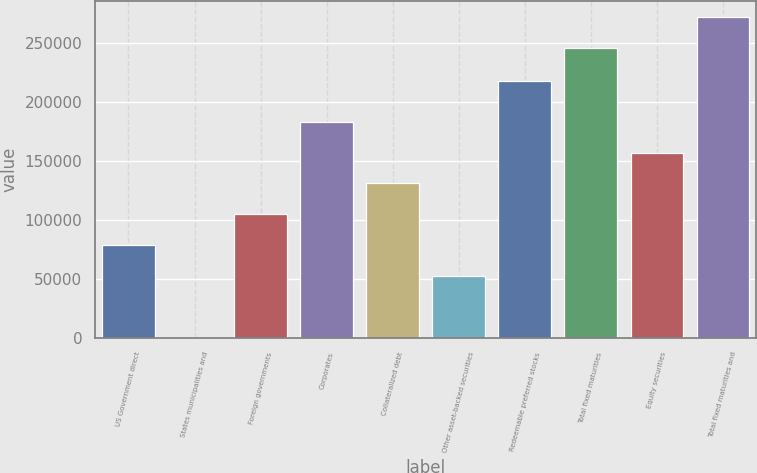Convert chart. <chart><loc_0><loc_0><loc_500><loc_500><bar_chart><fcel>US Government direct<fcel>States municipalities and<fcel>Foreign governments<fcel>Corporates<fcel>Collateralized debt<fcel>Other asset-backed securities<fcel>Redeemable preferred stocks<fcel>Total fixed maturities<fcel>Equity securities<fcel>Total fixed maturities and<nl><fcel>78616.7<fcel>2.05<fcel>104822<fcel>183436<fcel>131027<fcel>52411.8<fcel>217613<fcel>245705<fcel>157231<fcel>271910<nl></chart> 